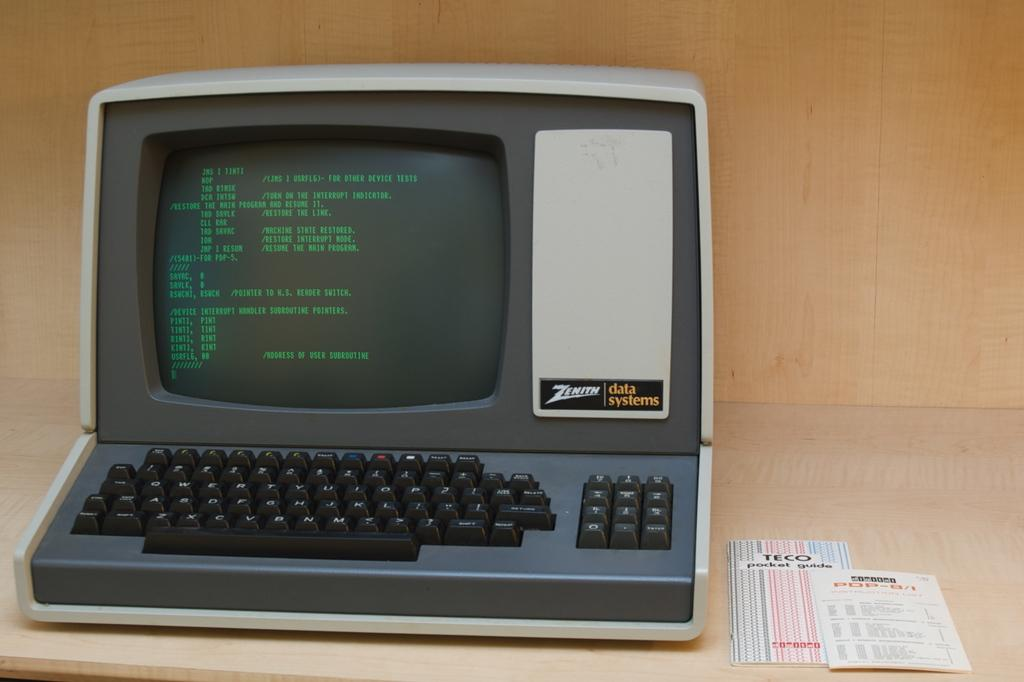<image>
Provide a brief description of the given image. An antique Zenith data systems computer and monitor all in one. 